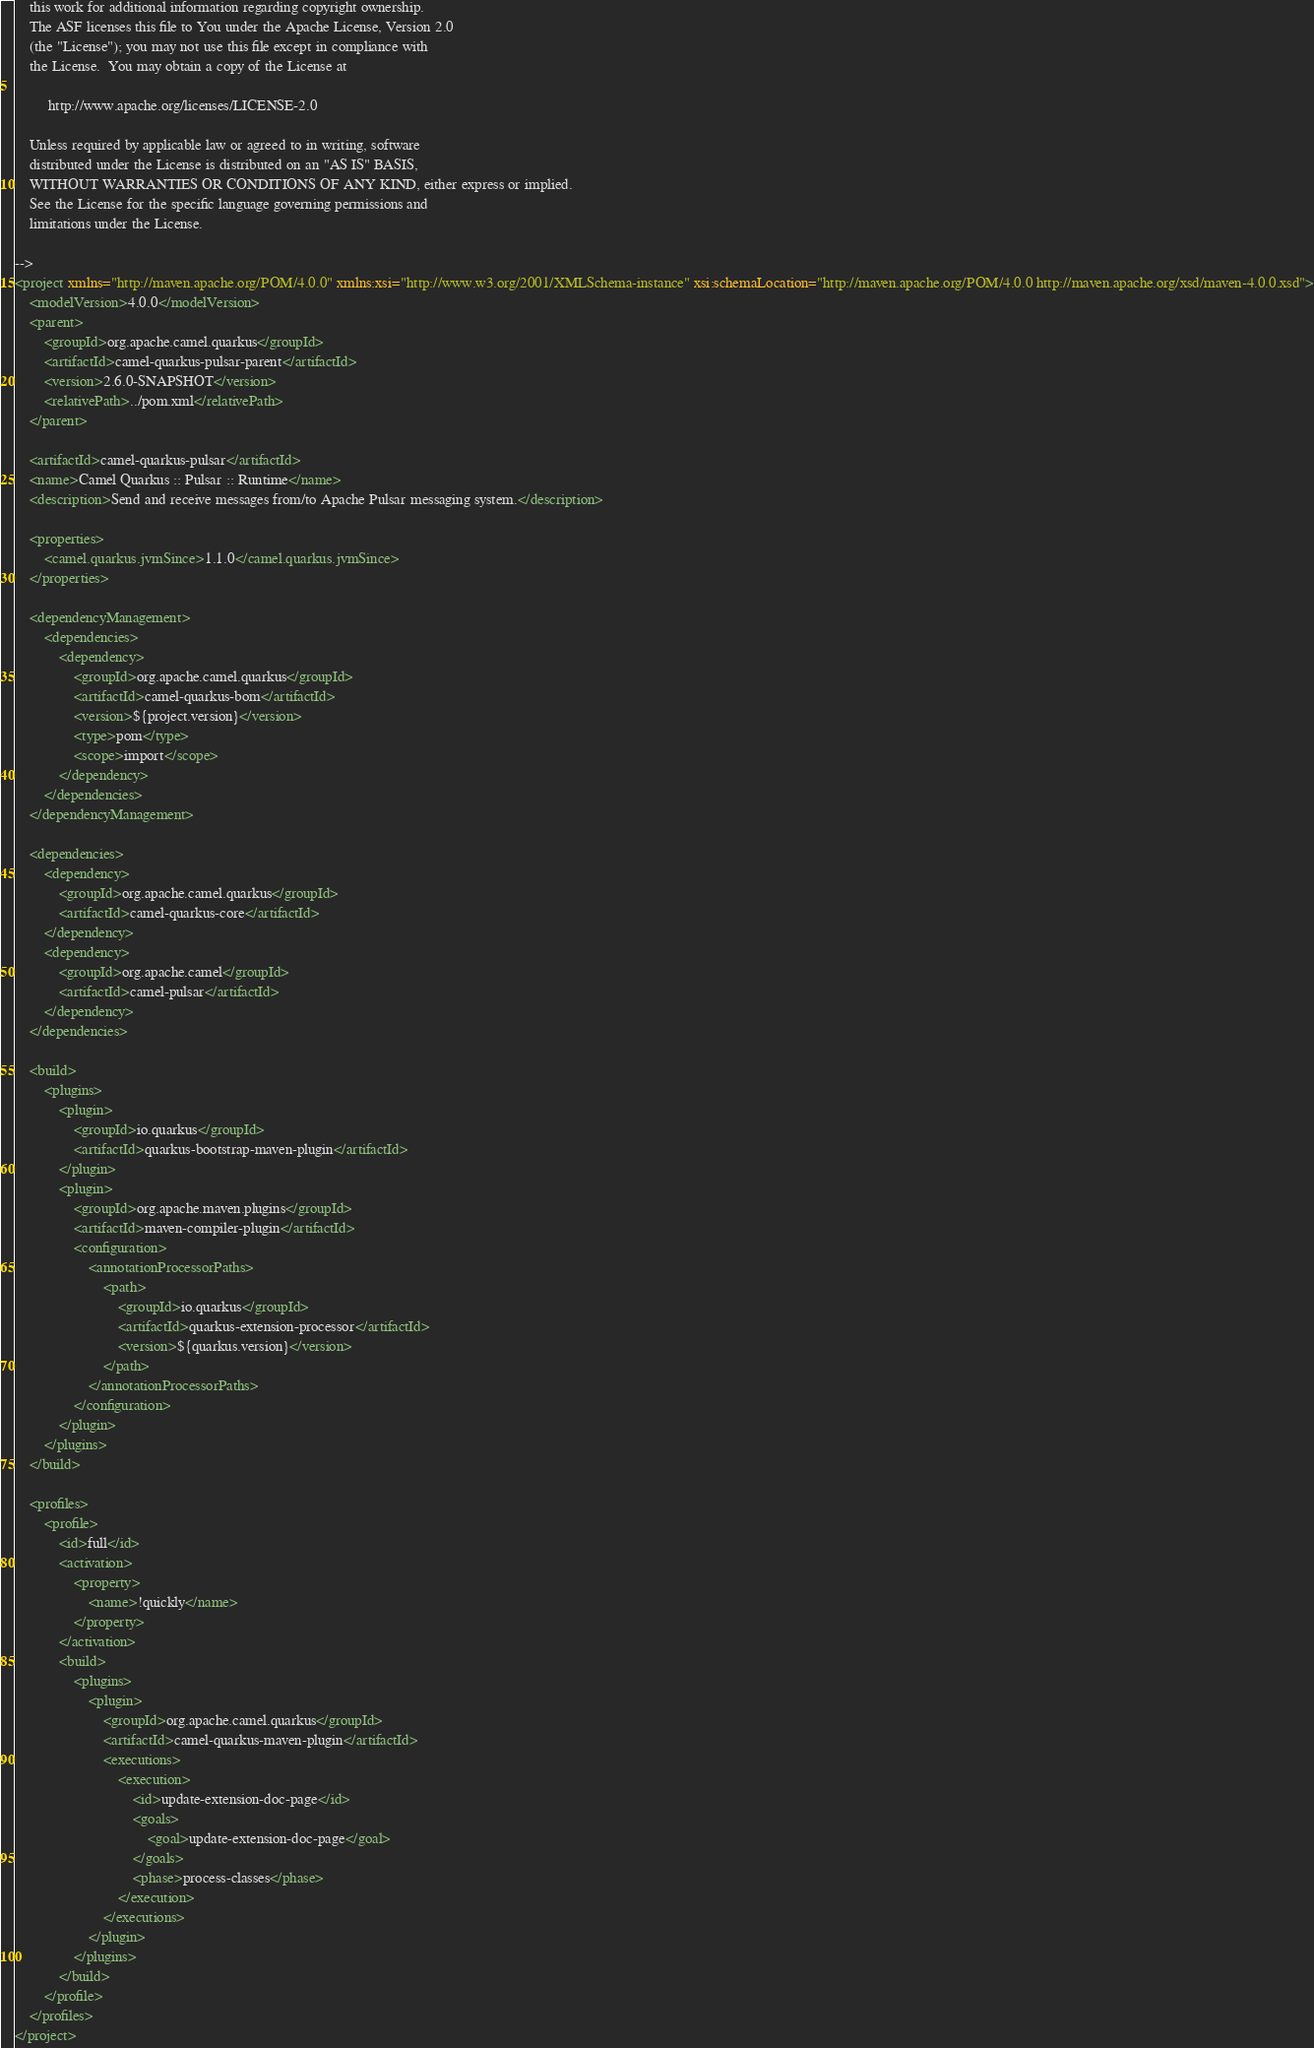Convert code to text. <code><loc_0><loc_0><loc_500><loc_500><_XML_>    this work for additional information regarding copyright ownership.
    The ASF licenses this file to You under the Apache License, Version 2.0
    (the "License"); you may not use this file except in compliance with
    the License.  You may obtain a copy of the License at

         http://www.apache.org/licenses/LICENSE-2.0

    Unless required by applicable law or agreed to in writing, software
    distributed under the License is distributed on an "AS IS" BASIS,
    WITHOUT WARRANTIES OR CONDITIONS OF ANY KIND, either express or implied.
    See the License for the specific language governing permissions and
    limitations under the License.

-->
<project xmlns="http://maven.apache.org/POM/4.0.0" xmlns:xsi="http://www.w3.org/2001/XMLSchema-instance" xsi:schemaLocation="http://maven.apache.org/POM/4.0.0 http://maven.apache.org/xsd/maven-4.0.0.xsd">
    <modelVersion>4.0.0</modelVersion>
    <parent>
        <groupId>org.apache.camel.quarkus</groupId>
        <artifactId>camel-quarkus-pulsar-parent</artifactId>
        <version>2.6.0-SNAPSHOT</version>
        <relativePath>../pom.xml</relativePath>
    </parent>

    <artifactId>camel-quarkus-pulsar</artifactId>
    <name>Camel Quarkus :: Pulsar :: Runtime</name>
    <description>Send and receive messages from/to Apache Pulsar messaging system.</description>

    <properties>
        <camel.quarkus.jvmSince>1.1.0</camel.quarkus.jvmSince>
    </properties>

    <dependencyManagement>
        <dependencies>
            <dependency>
                <groupId>org.apache.camel.quarkus</groupId>
                <artifactId>camel-quarkus-bom</artifactId>
                <version>${project.version}</version>
                <type>pom</type>
                <scope>import</scope>
            </dependency>
        </dependencies>
    </dependencyManagement>

    <dependencies>
        <dependency>
            <groupId>org.apache.camel.quarkus</groupId>
            <artifactId>camel-quarkus-core</artifactId>
        </dependency>
        <dependency>
            <groupId>org.apache.camel</groupId>
            <artifactId>camel-pulsar</artifactId>
        </dependency>
    </dependencies>

    <build>
        <plugins>
            <plugin>
                <groupId>io.quarkus</groupId>
                <artifactId>quarkus-bootstrap-maven-plugin</artifactId>
            </plugin>
            <plugin>
                <groupId>org.apache.maven.plugins</groupId>
                <artifactId>maven-compiler-plugin</artifactId>
                <configuration>
                    <annotationProcessorPaths>
                        <path>
                            <groupId>io.quarkus</groupId>
                            <artifactId>quarkus-extension-processor</artifactId>
                            <version>${quarkus.version}</version>
                        </path>
                    </annotationProcessorPaths>
                </configuration>
            </plugin>
        </plugins>
    </build>

    <profiles>
        <profile>
            <id>full</id>
            <activation>
                <property>
                    <name>!quickly</name>
                </property>
            </activation>
            <build>
                <plugins>
                    <plugin>
                        <groupId>org.apache.camel.quarkus</groupId>
                        <artifactId>camel-quarkus-maven-plugin</artifactId>
                        <executions>
                            <execution>
                                <id>update-extension-doc-page</id>
                                <goals>
                                    <goal>update-extension-doc-page</goal>
                                </goals>
                                <phase>process-classes</phase>
                            </execution>
                        </executions>
                    </plugin>
                </plugins>
            </build>
        </profile>
    </profiles>
</project>
</code> 